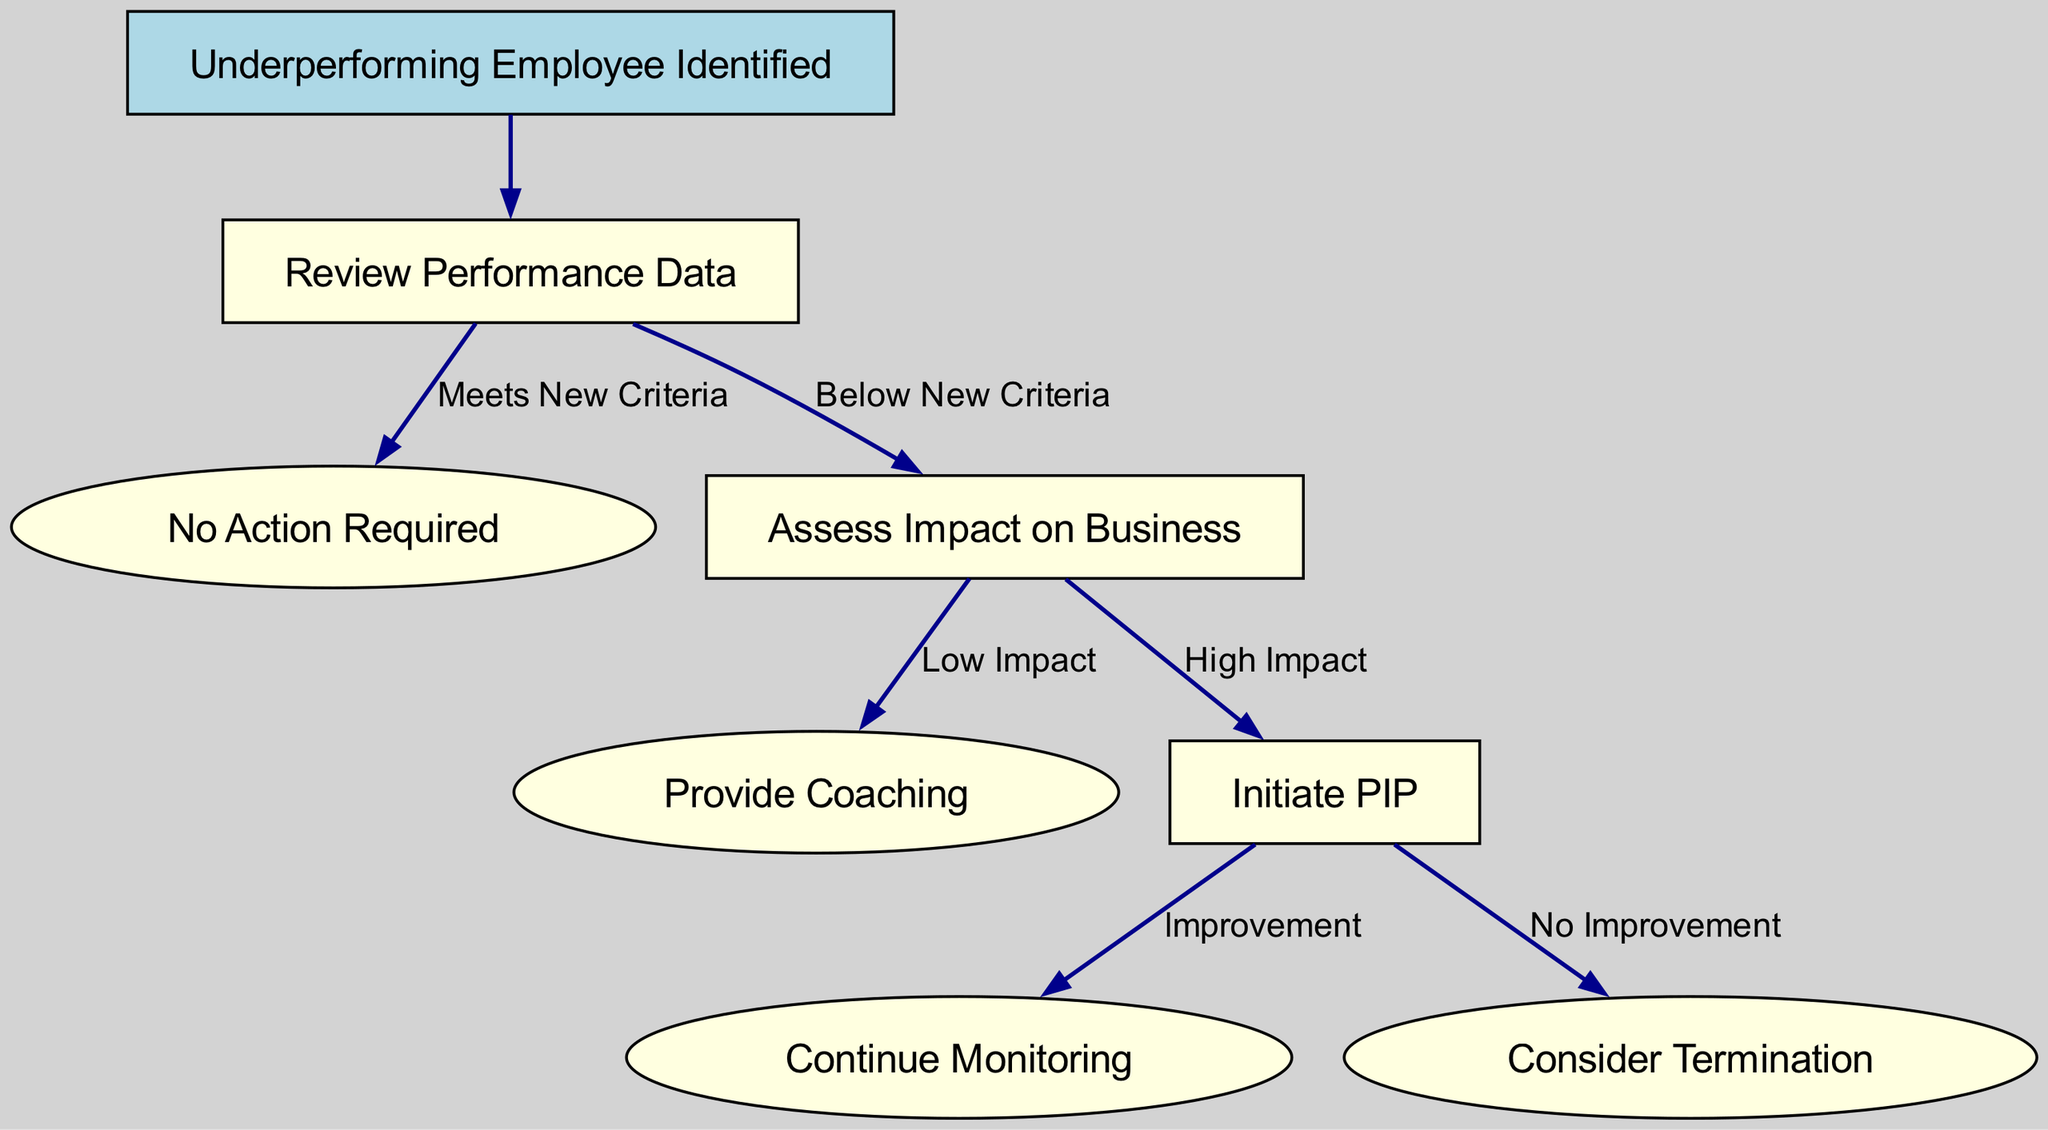What is the initial condition for the decision tree? The root node states "Underperforming Employee Identified," which indicates that the tree's initial condition pertains to recognizing an underperforming employee.
Answer: Underperforming Employee Identified How many options are available after reviewing performance data? After the "Review Performance Data" node, there are two options: "Meets New Criteria" and "Below New Criteria."
Answer: Two What happens if the performance is below new criteria but assessed as low impact? If the performance is determined to be below new criteria and assessed as having low impact, the next step is to "Provide Coaching."
Answer: Provide Coaching What is the outcome if there is no improvement after initiating a PIP? If after initiating a PIP there is assessed to be no improvement, the recommendation is to "Consider Termination."
Answer: Consider Termination What is the first action taken under the branch for high impact after assessing performance? The first action taken under high impact after assessing performance is to "Initiate PIP."
Answer: Initiate PIP What node follows "Assess Impact on Business" when the impact is high? When the impact is assessed as high, the node that follows is "Initiate PIP."
Answer: Initiate PIP If an employee meets the new criteria, what action is taken? If an employee meets the new criteria, the action taken is "No Action Required."
Answer: No Action Required What are the two possible outcomes after initiating a PIP? The two possible outcomes after initiating a PIP are "Improvement" and "No Improvement."
Answer: Improvement, No Improvement What type of node is represented at the decision to review performance data? The node that represents reviewing performance data is a decision node, indicating it has options leading to further actions.
Answer: Decision Node 